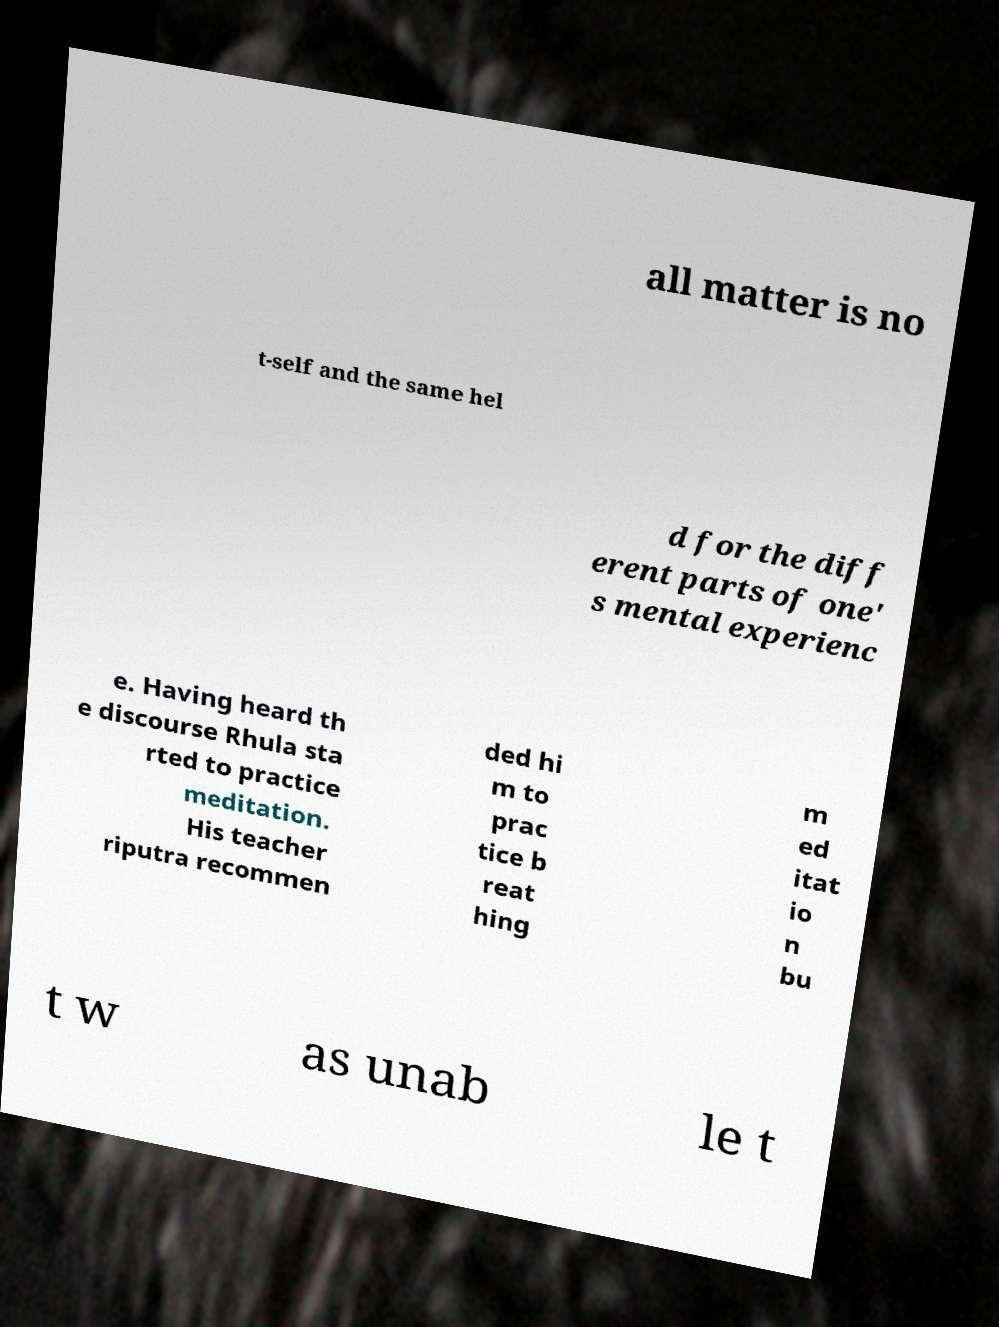There's text embedded in this image that I need extracted. Can you transcribe it verbatim? all matter is no t-self and the same hel d for the diff erent parts of one' s mental experienc e. Having heard th e discourse Rhula sta rted to practice meditation. His teacher riputra recommen ded hi m to prac tice b reat hing m ed itat io n bu t w as unab le t 